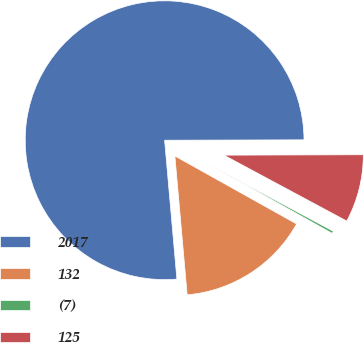Convert chart. <chart><loc_0><loc_0><loc_500><loc_500><pie_chart><fcel>2017<fcel>132<fcel>(7)<fcel>125<nl><fcel>76.37%<fcel>15.49%<fcel>0.27%<fcel>7.88%<nl></chart> 